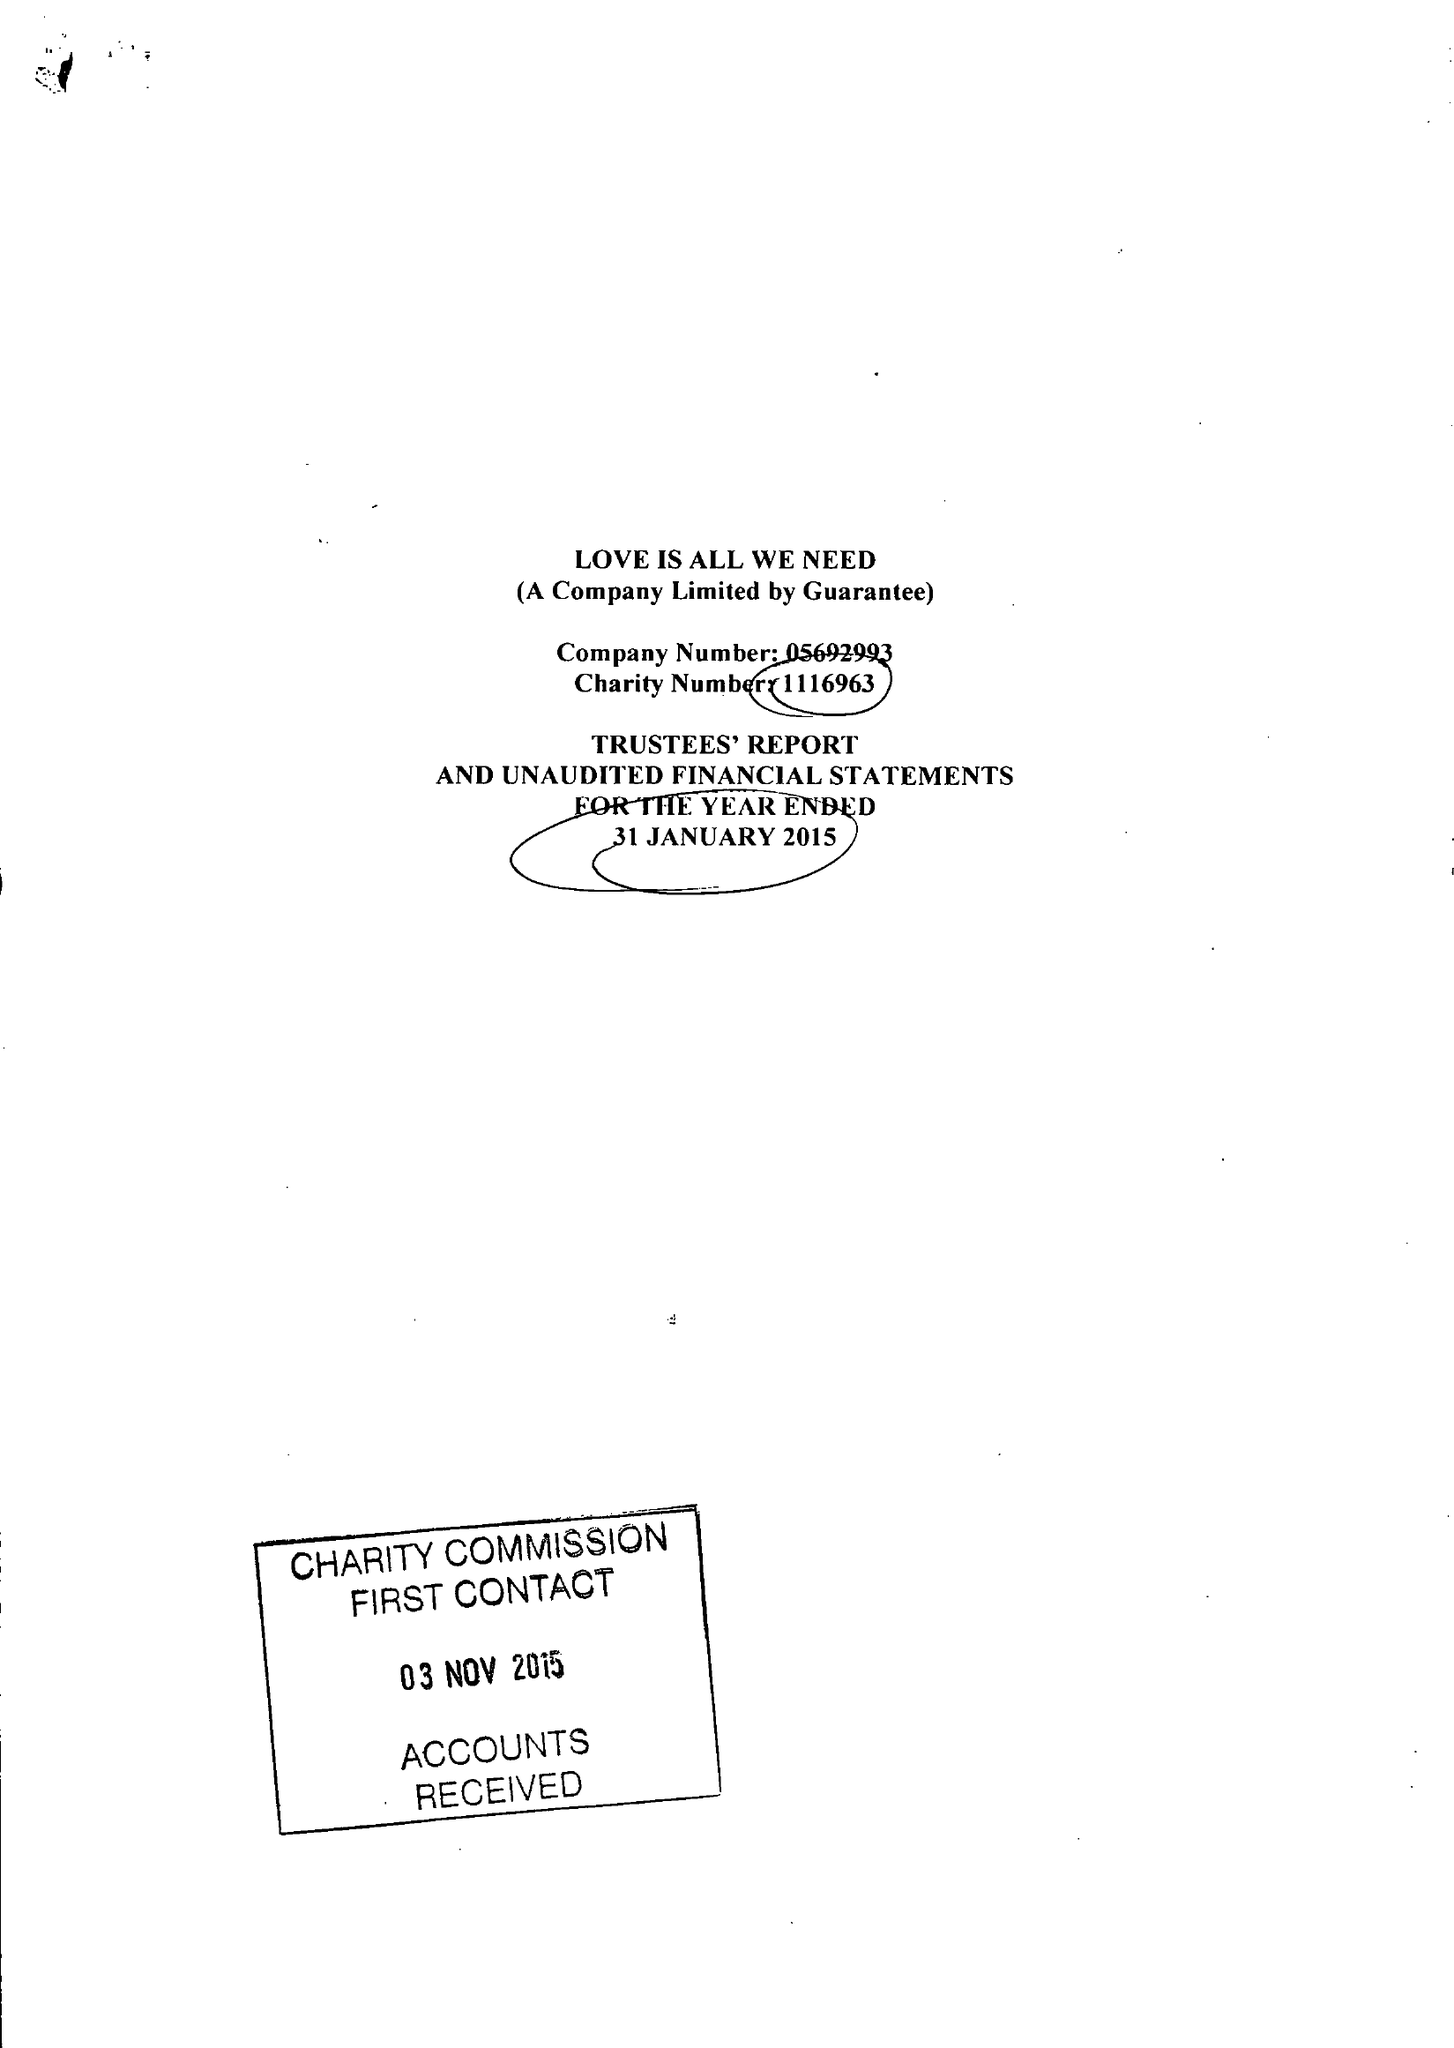What is the value for the address__postcode?
Answer the question using a single word or phrase. BN3 4FE 